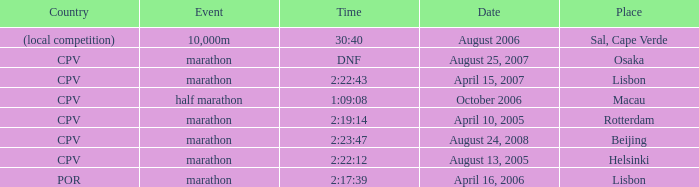What is the occasion named country of (regional contest)? 10,000m. 